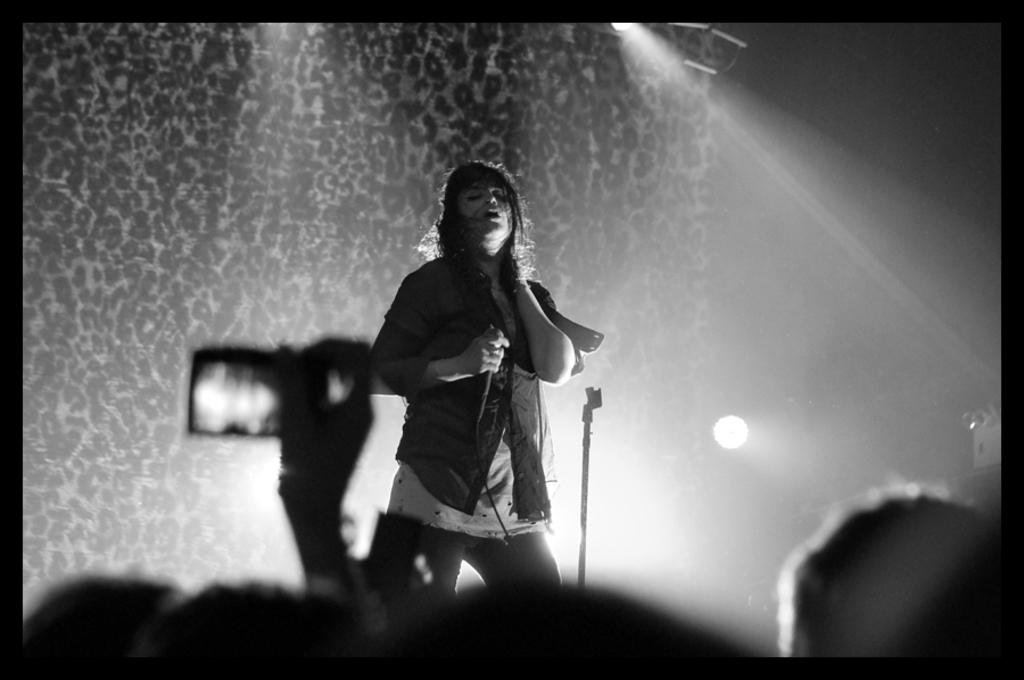What is the main subject of the image? There is a woman standing in the middle of the image. What is the woman holding in the image? The woman is holding a microphone. What can be seen behind the woman in the image? There is a wall behind the woman. What are the people at the bottom of the image doing? There are people standing at the bottom of the image, and one person is holding a mobile. How many balls are visible in the image? There are no balls present in the image. What type of screw is being used to hold the wall together in the image? There is no visible screw in the image, and the wall's construction is not mentioned. 